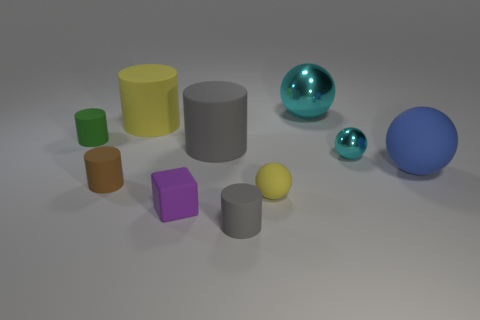Are there any other things that are the same shape as the tiny purple rubber thing?
Offer a very short reply. No. What material is the yellow object that is behind the cyan object in front of the green object?
Provide a short and direct response. Rubber. Are there any other large metal objects that have the same shape as the blue thing?
Make the answer very short. Yes. There is a big yellow rubber object; what shape is it?
Your response must be concise. Cylinder. There is a yellow thing on the right side of the gray rubber thing in front of the cube that is in front of the large cyan object; what is it made of?
Provide a short and direct response. Rubber. Are there more purple rubber cubes that are behind the big blue thing than big green blocks?
Provide a short and direct response. No. What material is the cyan thing that is the same size as the green thing?
Provide a succinct answer. Metal. Is there a brown rubber thing that has the same size as the purple object?
Ensure brevity in your answer.  Yes. There is a cyan shiny sphere behind the yellow cylinder; how big is it?
Offer a very short reply. Large. The green cylinder has what size?
Your answer should be compact. Small. 